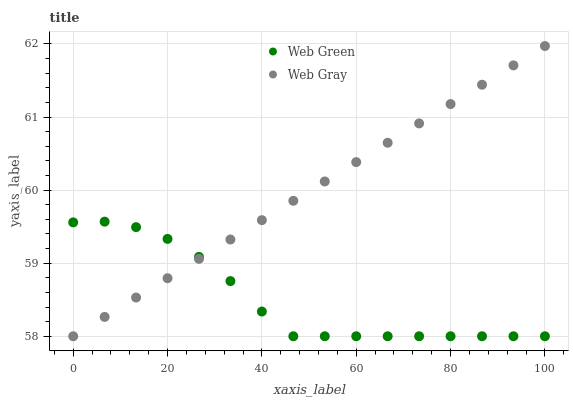Does Web Green have the minimum area under the curve?
Answer yes or no. Yes. Does Web Gray have the maximum area under the curve?
Answer yes or no. Yes. Does Web Green have the maximum area under the curve?
Answer yes or no. No. Is Web Gray the smoothest?
Answer yes or no. Yes. Is Web Green the roughest?
Answer yes or no. Yes. Is Web Green the smoothest?
Answer yes or no. No. Does Web Gray have the lowest value?
Answer yes or no. Yes. Does Web Gray have the highest value?
Answer yes or no. Yes. Does Web Green have the highest value?
Answer yes or no. No. Does Web Green intersect Web Gray?
Answer yes or no. Yes. Is Web Green less than Web Gray?
Answer yes or no. No. Is Web Green greater than Web Gray?
Answer yes or no. No. 